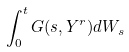Convert formula to latex. <formula><loc_0><loc_0><loc_500><loc_500>\int _ { 0 } ^ { t } G ( s , Y ^ { r } ) d W _ { s }</formula> 